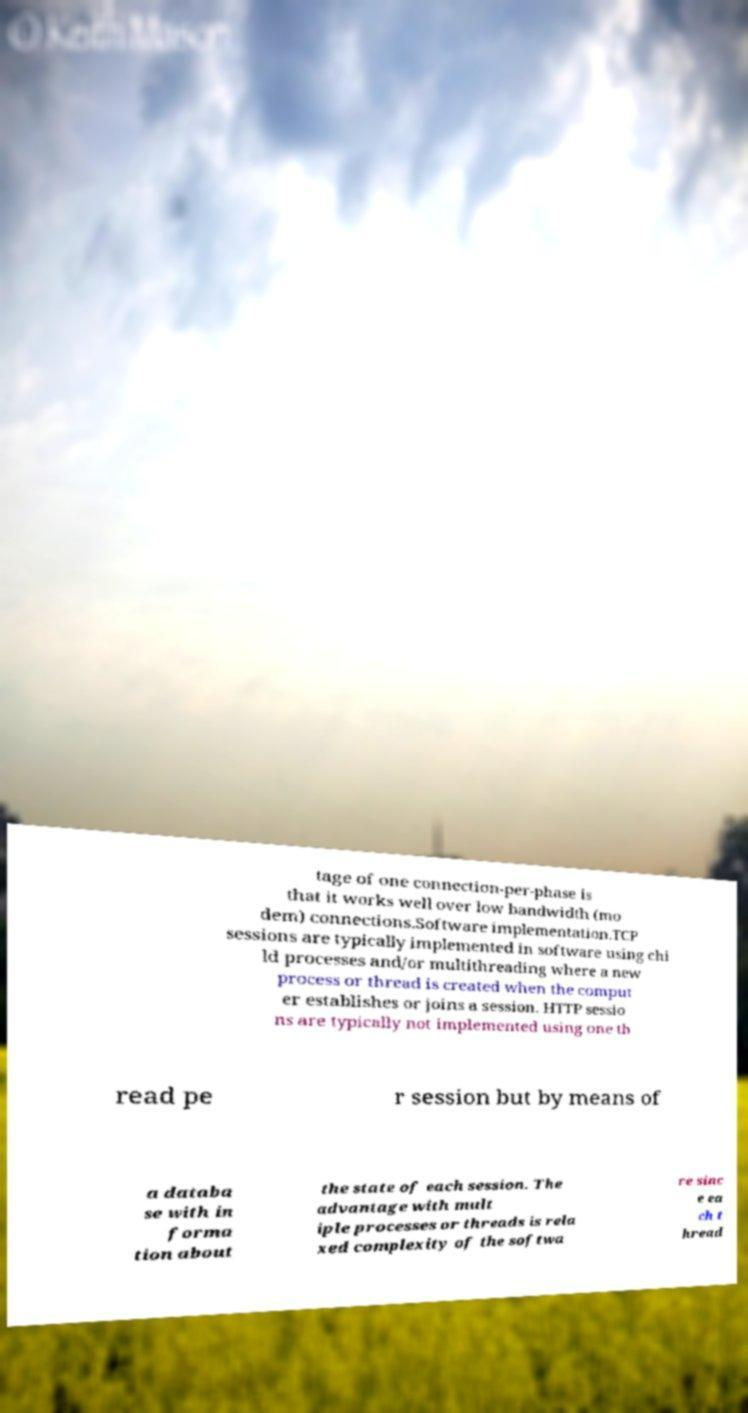What messages or text are displayed in this image? I need them in a readable, typed format. tage of one connection-per-phase is that it works well over low bandwidth (mo dem) connections.Software implementation.TCP sessions are typically implemented in software using chi ld processes and/or multithreading where a new process or thread is created when the comput er establishes or joins a session. HTTP sessio ns are typically not implemented using one th read pe r session but by means of a databa se with in forma tion about the state of each session. The advantage with mult iple processes or threads is rela xed complexity of the softwa re sinc e ea ch t hread 